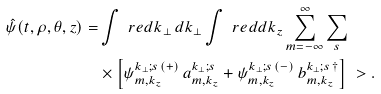<formula> <loc_0><loc_0><loc_500><loc_500>\hat { \psi } ( t , \rho , \theta , z ) = & \int \ r e d { k _ { \perp } \, d k _ { \perp } } \int \ r e d { d k _ { z } } \sum _ { m = - \infty } ^ { \infty } \sum _ { s } \\ & \times \left [ \psi ^ { k _ { \perp } ; s \, ( + ) } _ { m , k _ { z } } \, a ^ { k _ { \perp } ; s } _ { m , k _ { z } } + \psi ^ { k _ { \perp } ; s \, ( - ) } _ { m , k _ { z } } \, b ^ { k _ { \perp } ; s \, \dag } _ { m , k _ { z } } \right ] \ > .</formula> 